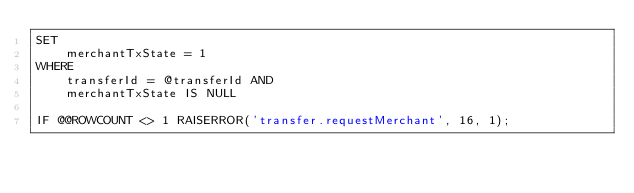Convert code to text. <code><loc_0><loc_0><loc_500><loc_500><_SQL_>SET
    merchantTxState = 1
WHERE
    transferId = @transferId AND
    merchantTxState IS NULL

IF @@ROWCOUNT <> 1 RAISERROR('transfer.requestMerchant', 16, 1);
</code> 